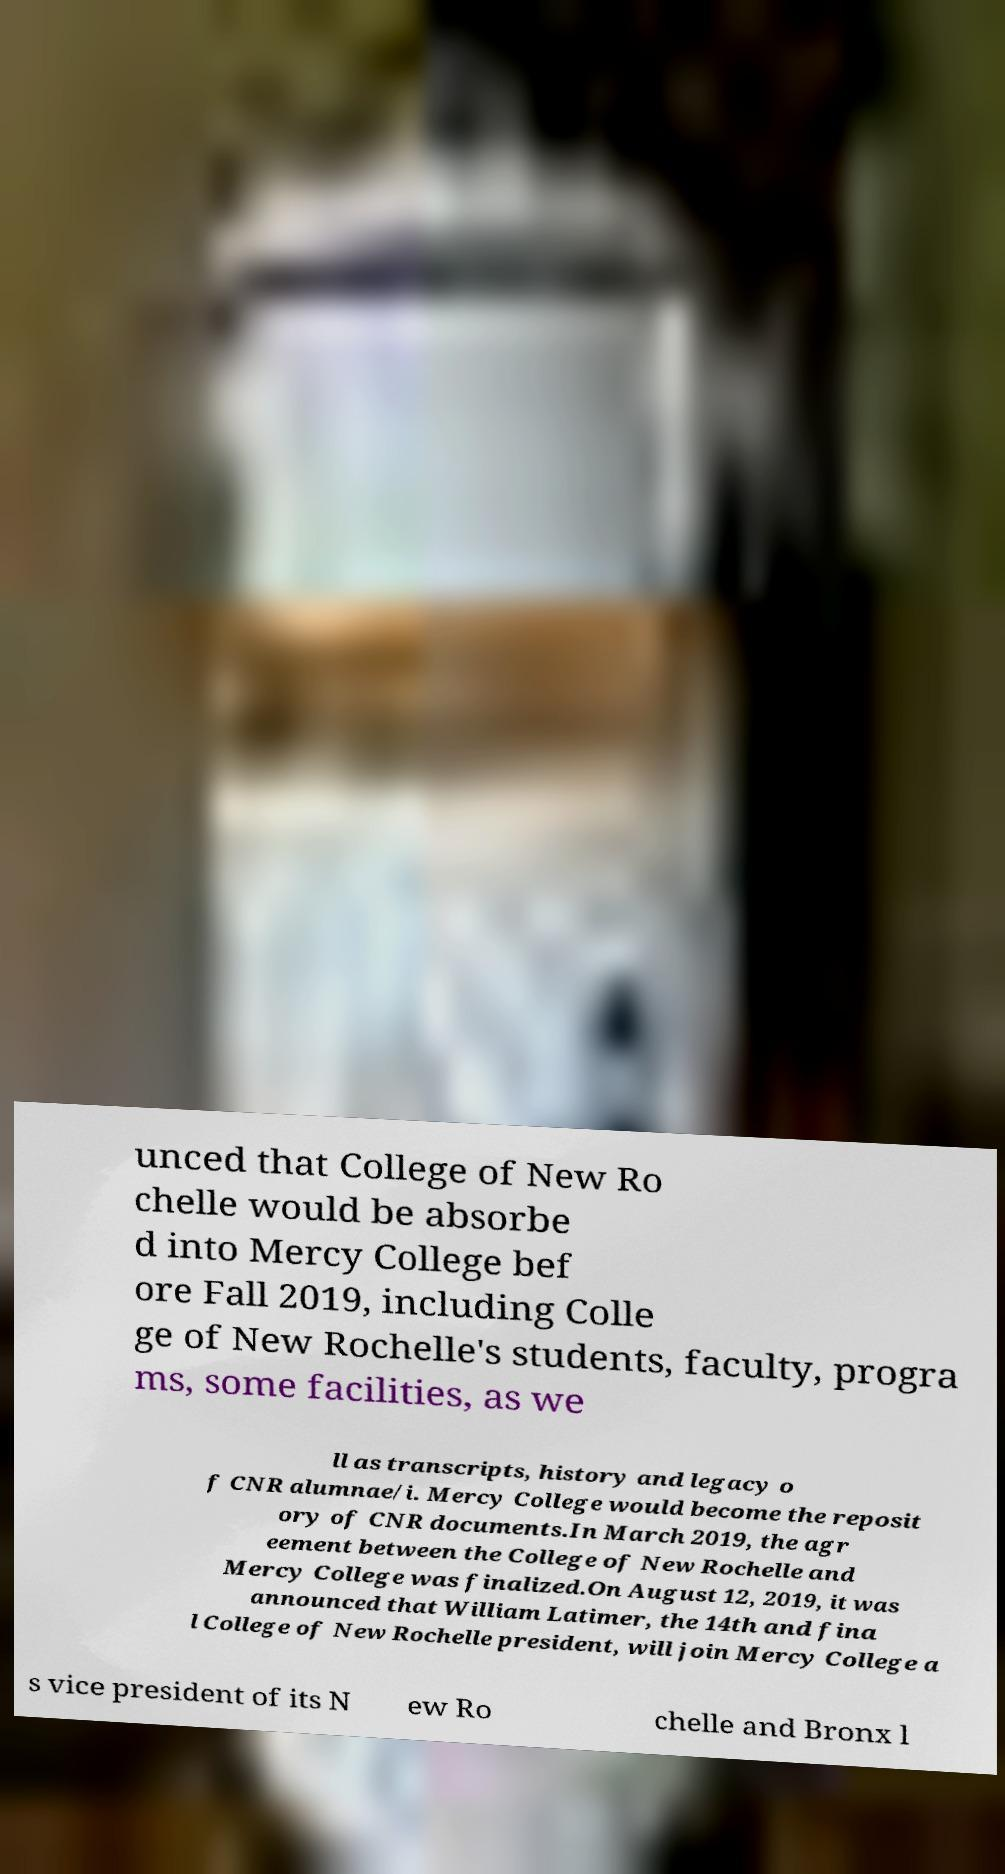Please read and relay the text visible in this image. What does it say? unced that College of New Ro chelle would be absorbe d into Mercy College bef ore Fall 2019, including Colle ge of New Rochelle's students, faculty, progra ms, some facilities, as we ll as transcripts, history and legacy o f CNR alumnae/i. Mercy College would become the reposit ory of CNR documents.In March 2019, the agr eement between the College of New Rochelle and Mercy College was finalized.On August 12, 2019, it was announced that William Latimer, the 14th and fina l College of New Rochelle president, will join Mercy College a s vice president of its N ew Ro chelle and Bronx l 